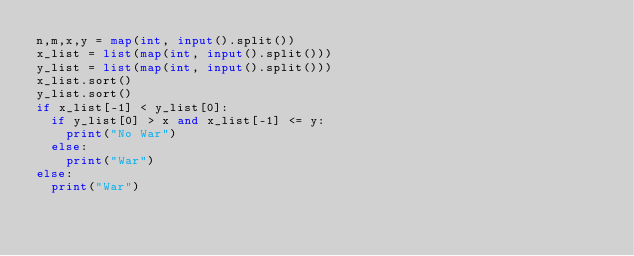<code> <loc_0><loc_0><loc_500><loc_500><_Python_>n,m,x,y = map(int, input().split())
x_list = list(map(int, input().split()))
y_list = list(map(int, input().split()))
x_list.sort()
y_list.sort()
if x_list[-1] < y_list[0]:
  if y_list[0] > x and x_list[-1] <= y:
    print("No War")
  else:
    print("War")
else:
  print("War")</code> 